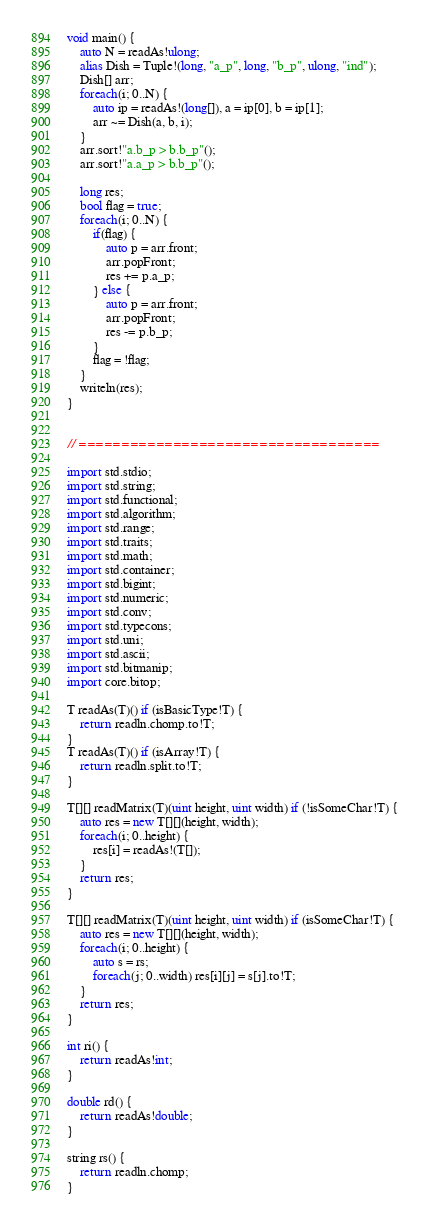<code> <loc_0><loc_0><loc_500><loc_500><_D_>void main() {
	auto N = readAs!ulong;
	alias Dish = Tuple!(long, "a_p", long, "b_p", ulong, "ind");
	Dish[] arr;
	foreach(i; 0..N) {
		auto ip = readAs!(long[]), a = ip[0], b = ip[1];
		arr ~= Dish(a, b, i);
	}
	arr.sort!"a.b_p > b.b_p"();
	arr.sort!"a.a_p > b.b_p"();
	
	long res;
	bool flag = true;
	foreach(i; 0..N) {
		if(flag) {
			auto p = arr.front;
			arr.popFront;
			res += p.a_p;
		} else {
			auto p = arr.front;
			arr.popFront;
			res -= p.b_p;
		}
		flag = !flag;
	}
	writeln(res);
}


// ===================================

import std.stdio;
import std.string;
import std.functional;
import std.algorithm;
import std.range;
import std.traits;
import std.math;
import std.container;
import std.bigint;
import std.numeric;
import std.conv;
import std.typecons;
import std.uni;
import std.ascii;
import std.bitmanip;
import core.bitop;

T readAs(T)() if (isBasicType!T) {
	return readln.chomp.to!T;
}
T readAs(T)() if (isArray!T) {
	return readln.split.to!T;
}

T[][] readMatrix(T)(uint height, uint width) if (!isSomeChar!T) {
	auto res = new T[][](height, width);
	foreach(i; 0..height) {
		res[i] = readAs!(T[]);
	}
	return res;
}

T[][] readMatrix(T)(uint height, uint width) if (isSomeChar!T) {
	auto res = new T[][](height, width);
	foreach(i; 0..height) {
		auto s = rs;
		foreach(j; 0..width) res[i][j] = s[j].to!T;
	}
	return res;
}

int ri() {
	return readAs!int;
}

double rd() {
	return readAs!double;
}

string rs() {
	return readln.chomp;
}
</code> 